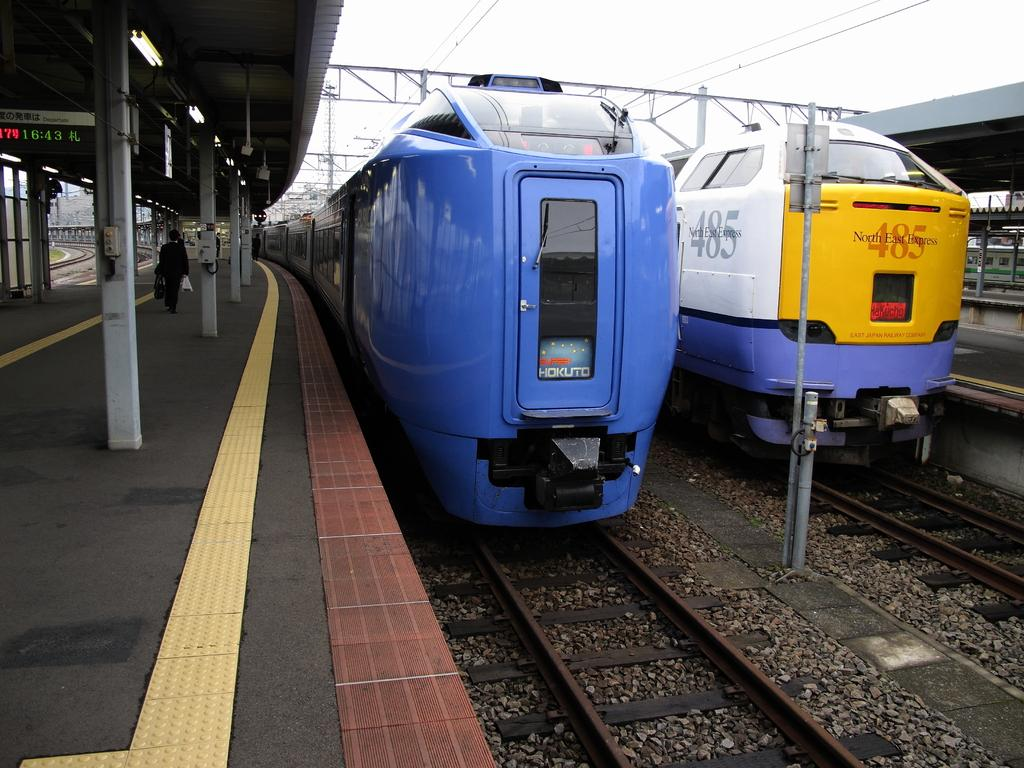<image>
Describe the image concisely. The 485 North East Express train sits at the train station. 